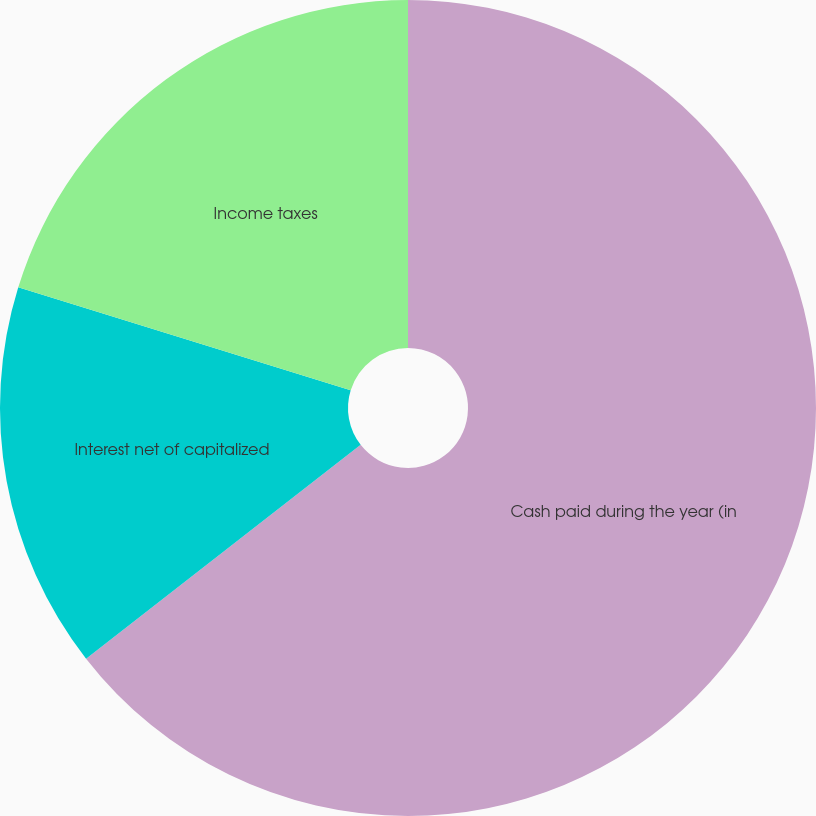<chart> <loc_0><loc_0><loc_500><loc_500><pie_chart><fcel>Cash paid during the year (in<fcel>Interest net of capitalized<fcel>Income taxes<nl><fcel>64.47%<fcel>15.31%<fcel>20.22%<nl></chart> 